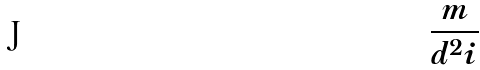Convert formula to latex. <formula><loc_0><loc_0><loc_500><loc_500>\frac { m } { d ^ { 2 } i }</formula> 